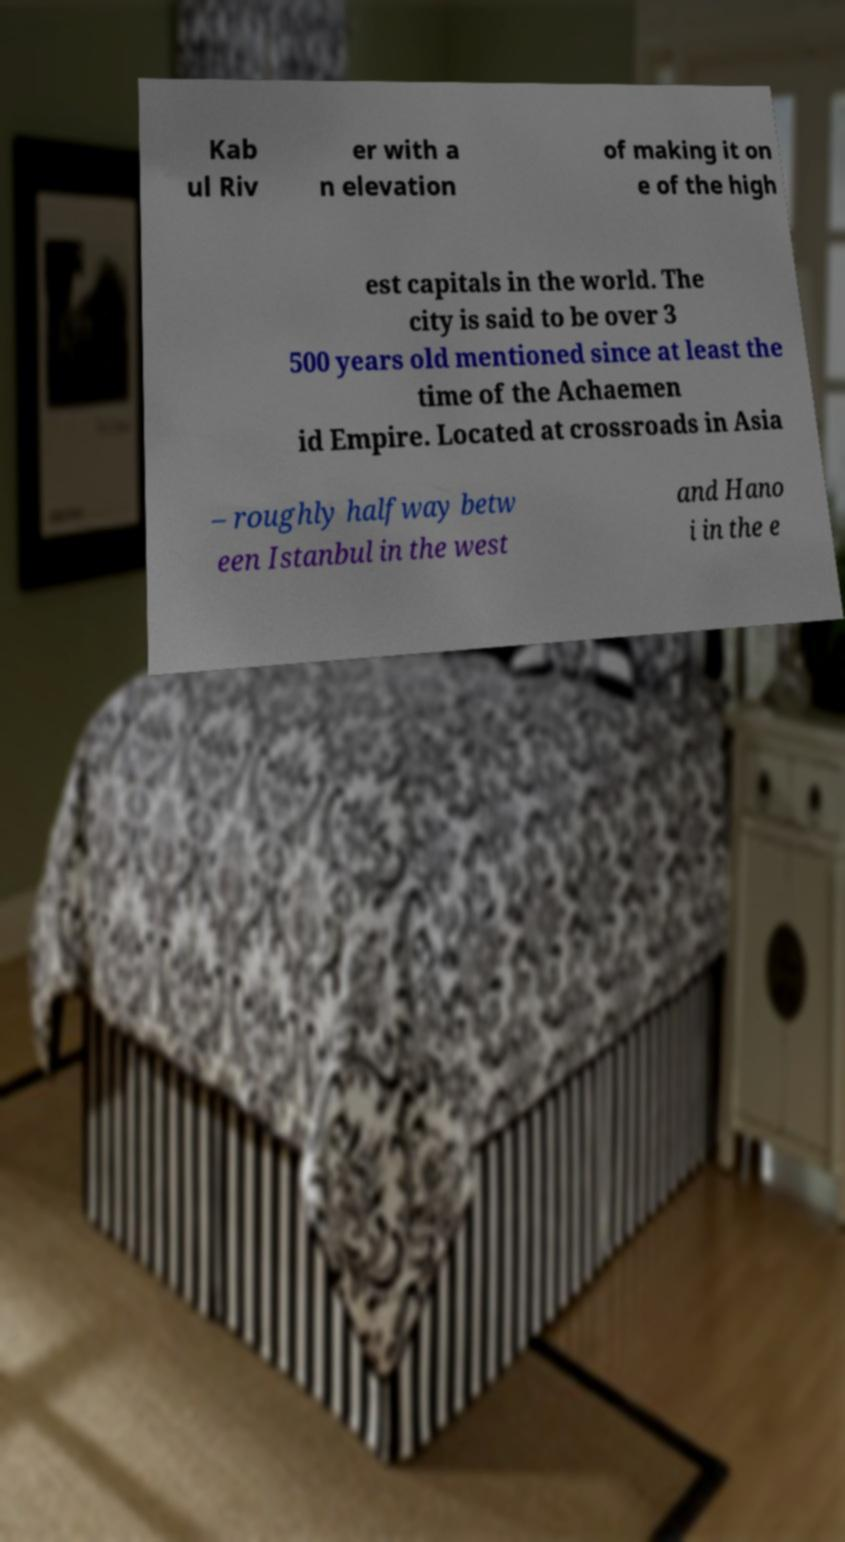There's text embedded in this image that I need extracted. Can you transcribe it verbatim? Kab ul Riv er with a n elevation of making it on e of the high est capitals in the world. The city is said to be over 3 500 years old mentioned since at least the time of the Achaemen id Empire. Located at crossroads in Asia – roughly halfway betw een Istanbul in the west and Hano i in the e 